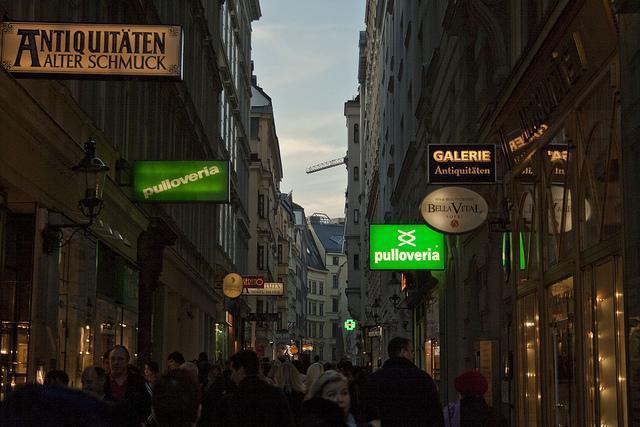How many people are wearing a Red Hat?
Give a very brief answer. 1. How many people are there?
Give a very brief answer. 3. How many people are wearing skis in this image?
Give a very brief answer. 0. 